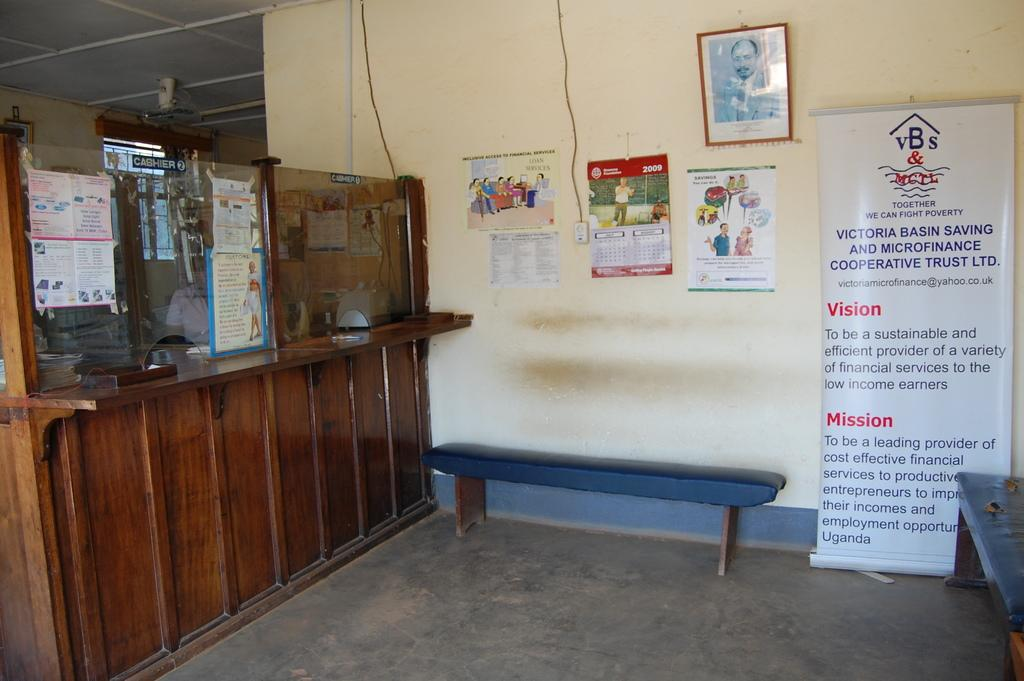What type of furniture is present in the image? There is a bench in the image. What is placed on the bench? There is a poster on the bench. What can be seen on the wall in the image? There are charts hung on the wall and a photo frame on the wall. What is the material of the wall on the left side of the image? The wall on the left side of the image is made of wood. What type of fish can be seen swimming in the poster on the bench? There is no fish present in the image, as the poster does not depict any aquatic life. 